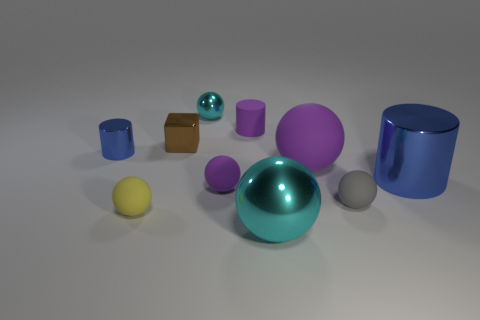Subtract 3 spheres. How many spheres are left? 3 Subtract all yellow spheres. How many spheres are left? 5 Subtract all big purple spheres. How many spheres are left? 5 Subtract all blue spheres. Subtract all green blocks. How many spheres are left? 6 Subtract all blocks. How many objects are left? 9 Add 4 small purple cylinders. How many small purple cylinders are left? 5 Add 10 tiny green rubber balls. How many tiny green rubber balls exist? 10 Subtract 0 gray cubes. How many objects are left? 10 Subtract all gray rubber things. Subtract all purple rubber cylinders. How many objects are left? 8 